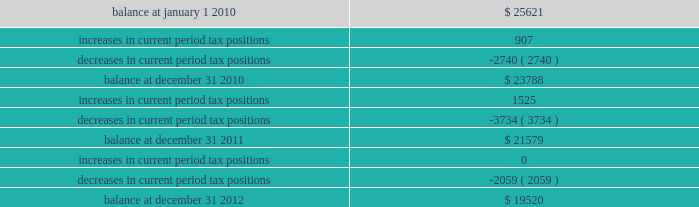The table summarizes the changes in the company 2019s valuation allowance: .
Note 14 : employee benefits pension and other postretirement benefits the company maintains noncontributory defined benefit pension plans covering eligible employees of its regulated utility and shared services operations .
Benefits under the plans are based on the employee 2019s years of service and compensation .
The pension plans have been closed for most employees hired on or after january 1 , 2006 .
Union employees hired on or after january 1 , 2001 had their accrued benefit frozen and will be able to receive this benefit as a lump sum upon termination or retirement .
Union employees hired on or after january 1 , 2001 and non-union employees hired on or after january 1 , 2006 are provided with a 5.25% ( 5.25 % ) of base pay defined contribution plan .
The company does not participate in a multiemployer plan .
The company 2019s funding policy is to contribute at least the greater of the minimum amount required by the employee retirement income security act of 1974 or the normal cost , and an additional contribution if needed to avoid 201cat risk 201d status and benefit restrictions under the pension protection act of 2006 .
The company may also increase its contributions , if appropriate , to its tax and cash position and the plan 2019s funded position .
Pension plan assets are invested in a number of actively managed and indexed investments including equity and bond mutual funds , fixed income securities and guaranteed interest contracts with insurance companies .
Pension expense in excess of the amount contributed to the pension plans is deferred by certain regulated subsidiaries pending future recovery in rates charged for utility services as contributions are made to the plans .
( see note 6 ) the company also has several unfunded noncontributory supplemental non-qualified pension plans that provide additional retirement benefits to certain employees .
The company maintains other postretirement benefit plans providing varying levels of medical and life insurance to eligible retirees .
The retiree welfare plans are closed for union employees hired on or after january 1 , 2006 .
The plans had previously closed for non-union employees hired on or after january 1 , 2002 .
The company 2019s policy is to fund other postretirement benefit costs for rate-making purposes .
Plan assets are invested in equity and bond mutual funds , fixed income securities , real estate investment trusts ( 201creits 201d ) and emerging market funds .
The obligations of the plans are dominated by obligations for active employees .
Because the timing of expected benefit payments is so far in the future and the size of the plan assets are small relative to the company 2019s assets , the investment strategy is to allocate a significant percentage of assets to equities , which the company believes will provide the highest return over the long-term period .
The fixed income assets are invested in long duration debt securities and may be invested in fixed income instruments , such as futures and options in order to better match the duration of the plan liability. .
How much did the company 2019s valuation allowance decrease from 2010 to 2012? 
Computations: ((19520 - 25621) / 25621)
Answer: -0.23812. 